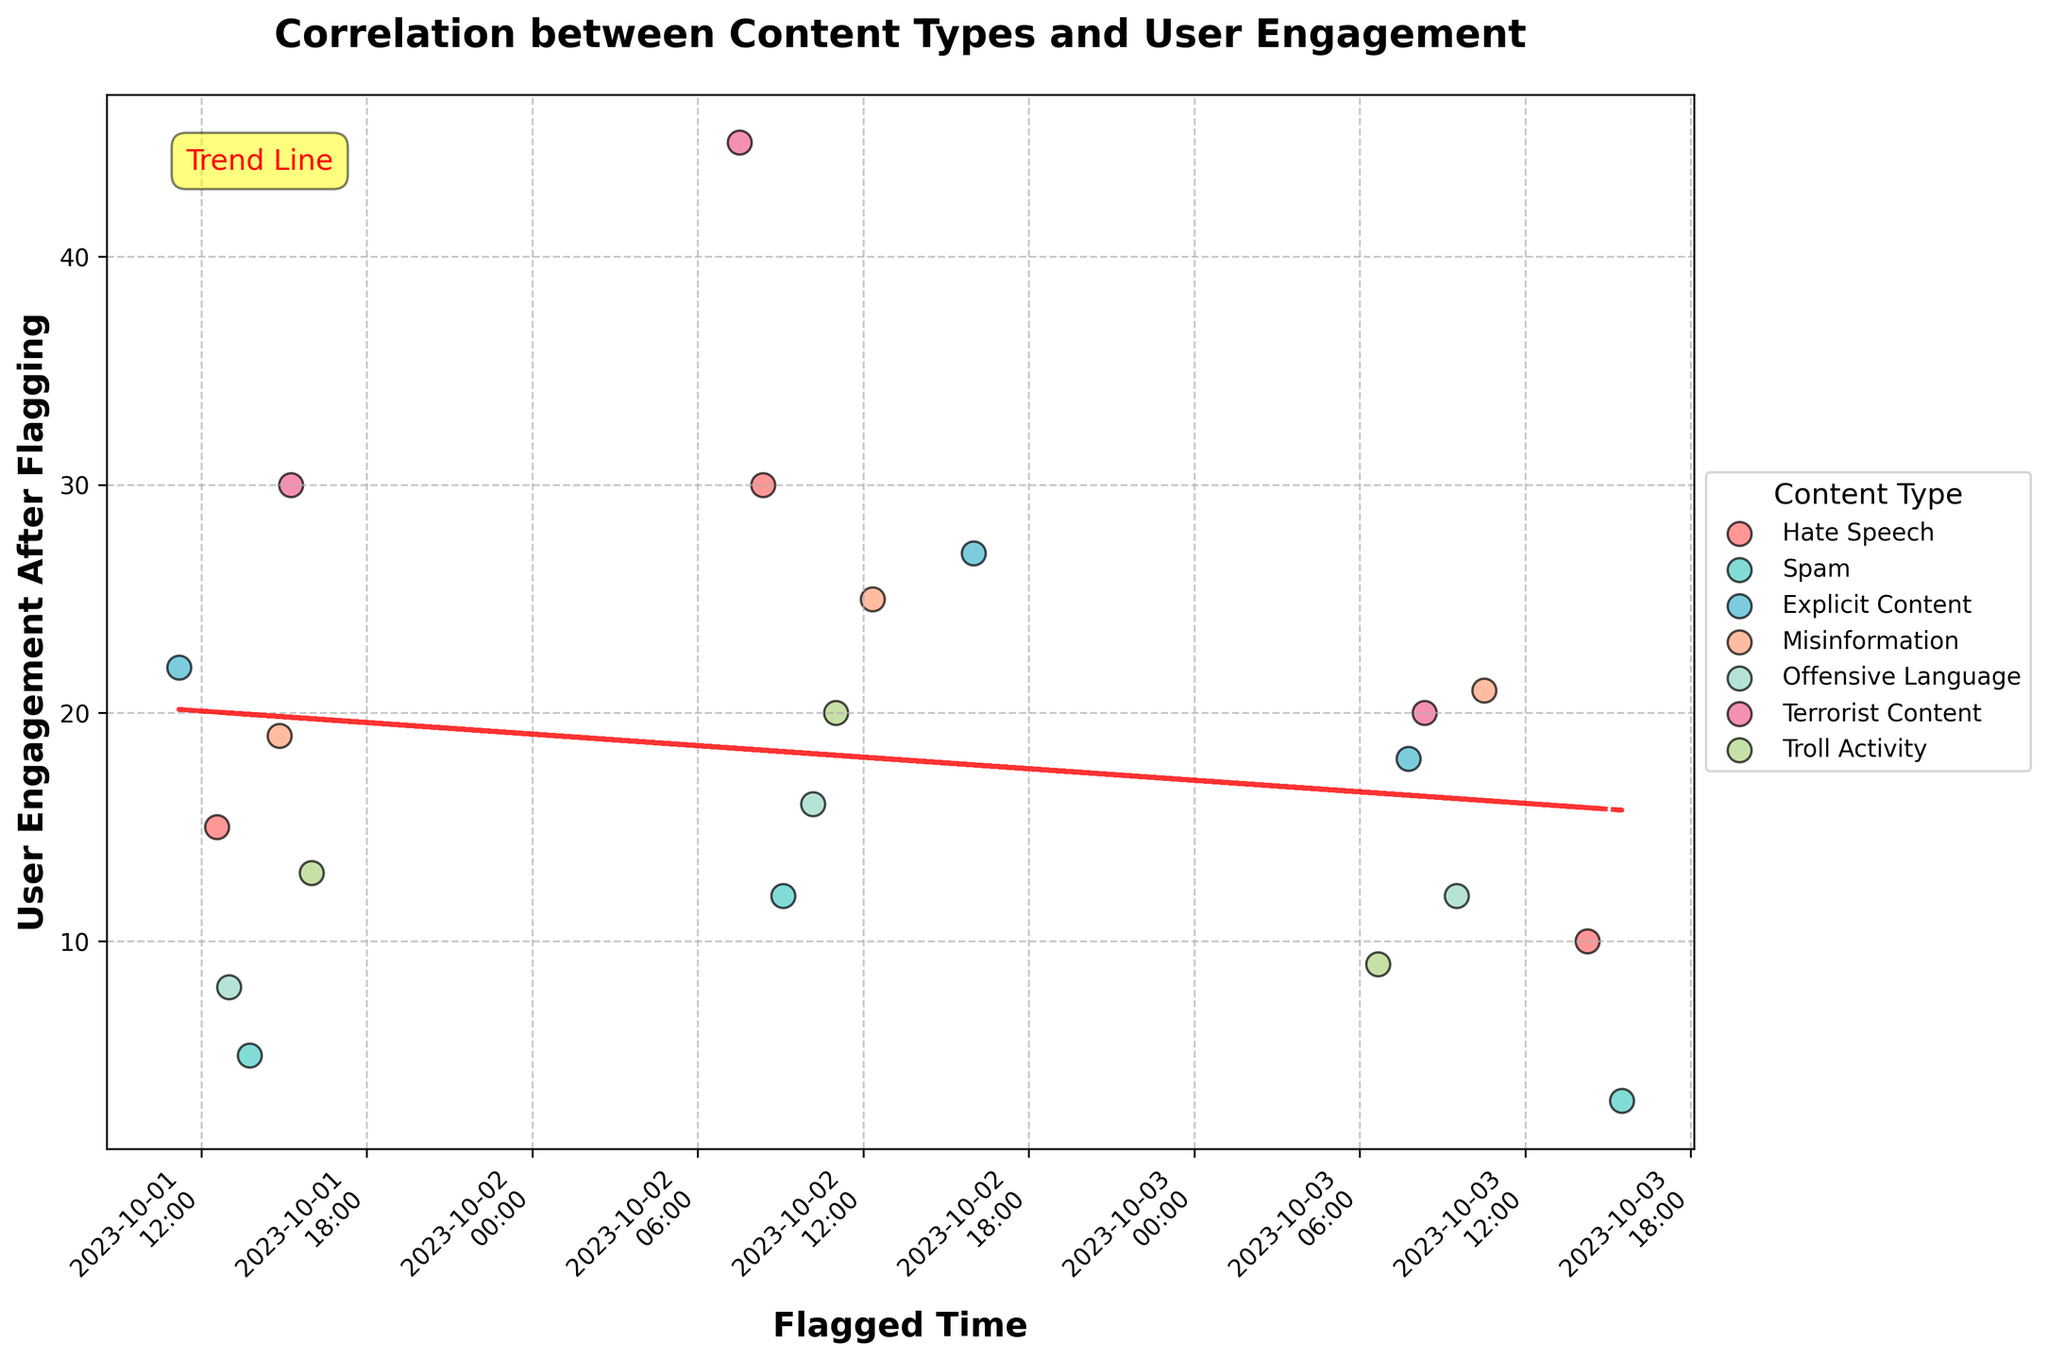Which content type shows the highest user engagement after being flagged? To find the content type with the highest user engagement, we need to look at the highest data point on the y-axis. The highest user engagement value is 45, which is associated with "Terrorist Content".
Answer: Terrorist Content Which content type has the lowest user engagement after being flagged? To find the content type with the lowest user engagement, we need to scan for the lowest point on the y-axis. The lowest engagement value is 3, which corresponds to "Spam".
Answer: Spam What is the general trend between the flagged time and user engagement after flagging, as shown by the trend line? The trend line, which is a dashed red line, shows whether there is an increase or decrease in user engagement over time. Here, the trend line slightly slopes downwards, indicating a slight decrease in engagement over time.
Answer: Slight decrease What is the user engagement range for Hate Speech after being flagged? To determine the range, identify the maximum and minimum engagement values for Hate Speech. The values for Hate Speech are 30, 15, and 10. The range is 30 (max) - 10 (min).
Answer: 20 Comparing "Hate Speech" and "Terrorist Content", which one shows more variability in user engagement after flagging? To compare variability, look at the range of engagement values for both types. Hate Speech ranges from 10 to 30, while Terrorist Content ranges from 20 to 45. "Terrorist Content" shows greater variability.
Answer: Terrorist Content How many different content types are represented in the scatter plot? Each content type is represented by a different color and label in the scatter plot. Counting the unique labels in the legend, there are 7 unique content types.
Answer: 7 Which content types have at least one data point with engagement higher than 25? We need to check the y-axis values for engagement levels higher than 25 and identify the corresponding content types. "Terrorist Content," "Hate Speech," "Explicit Content," and "Misinformation" all have points above 25.
Answer: Terrorist Content, Hate Speech, Explicit Content, Misinformation 